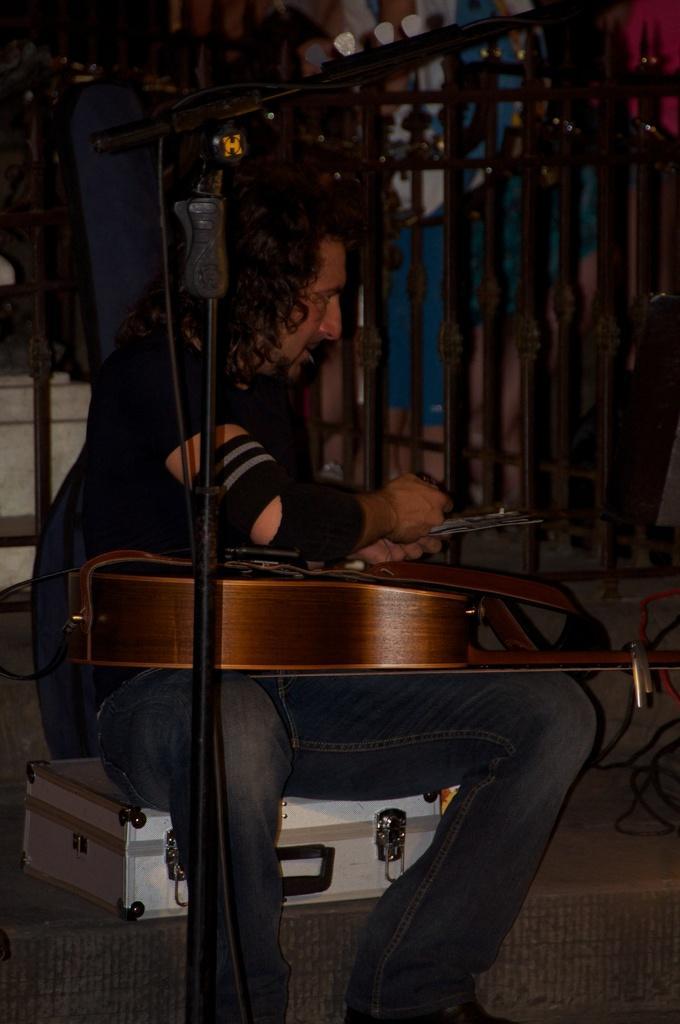Can you describe this image briefly? As we can see in the image there is a man sitting on suitcase and holding guitar. There is mic and fence. 